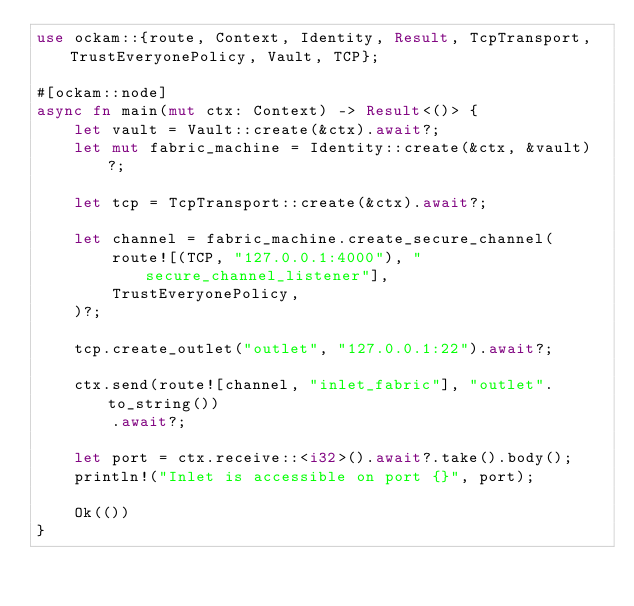<code> <loc_0><loc_0><loc_500><loc_500><_Rust_>use ockam::{route, Context, Identity, Result, TcpTransport, TrustEveryonePolicy, Vault, TCP};

#[ockam::node]
async fn main(mut ctx: Context) -> Result<()> {
    let vault = Vault::create(&ctx).await?;
    let mut fabric_machine = Identity::create(&ctx, &vault)?;

    let tcp = TcpTransport::create(&ctx).await?;

    let channel = fabric_machine.create_secure_channel(
        route![(TCP, "127.0.0.1:4000"), "secure_channel_listener"],
        TrustEveryonePolicy,
    )?;

    tcp.create_outlet("outlet", "127.0.0.1:22").await?;

    ctx.send(route![channel, "inlet_fabric"], "outlet".to_string())
        .await?;

    let port = ctx.receive::<i32>().await?.take().body();
    println!("Inlet is accessible on port {}", port);

    Ok(())
}
</code> 